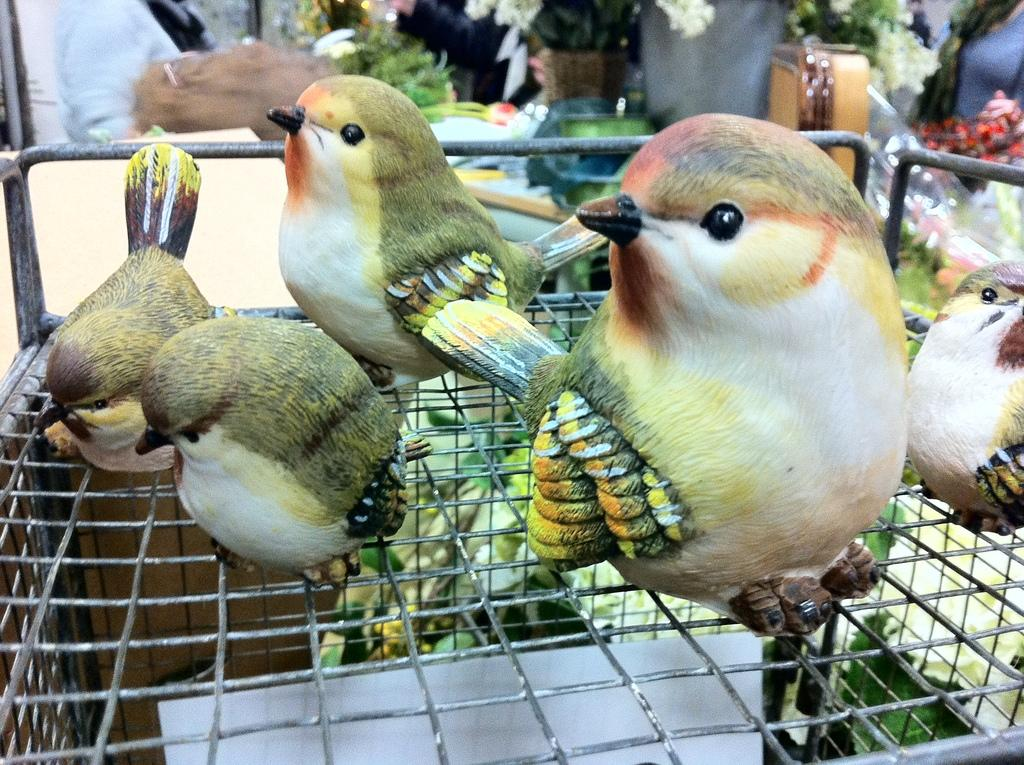What type of animals are represented by the toys in the image? There are toy birds on a cage in the image. What other elements can be seen in the image besides the toy birds? There are flowers, plants, and other objects in the image. Can you describe the person's position in the image? There is a person behind the cage in the image. What type of leather material is used to make the art piece in the image? There is no art piece made of leather present in the image. Can you hear the person in the image crying? The image is a still picture, so there is no sound or indication of crying. 